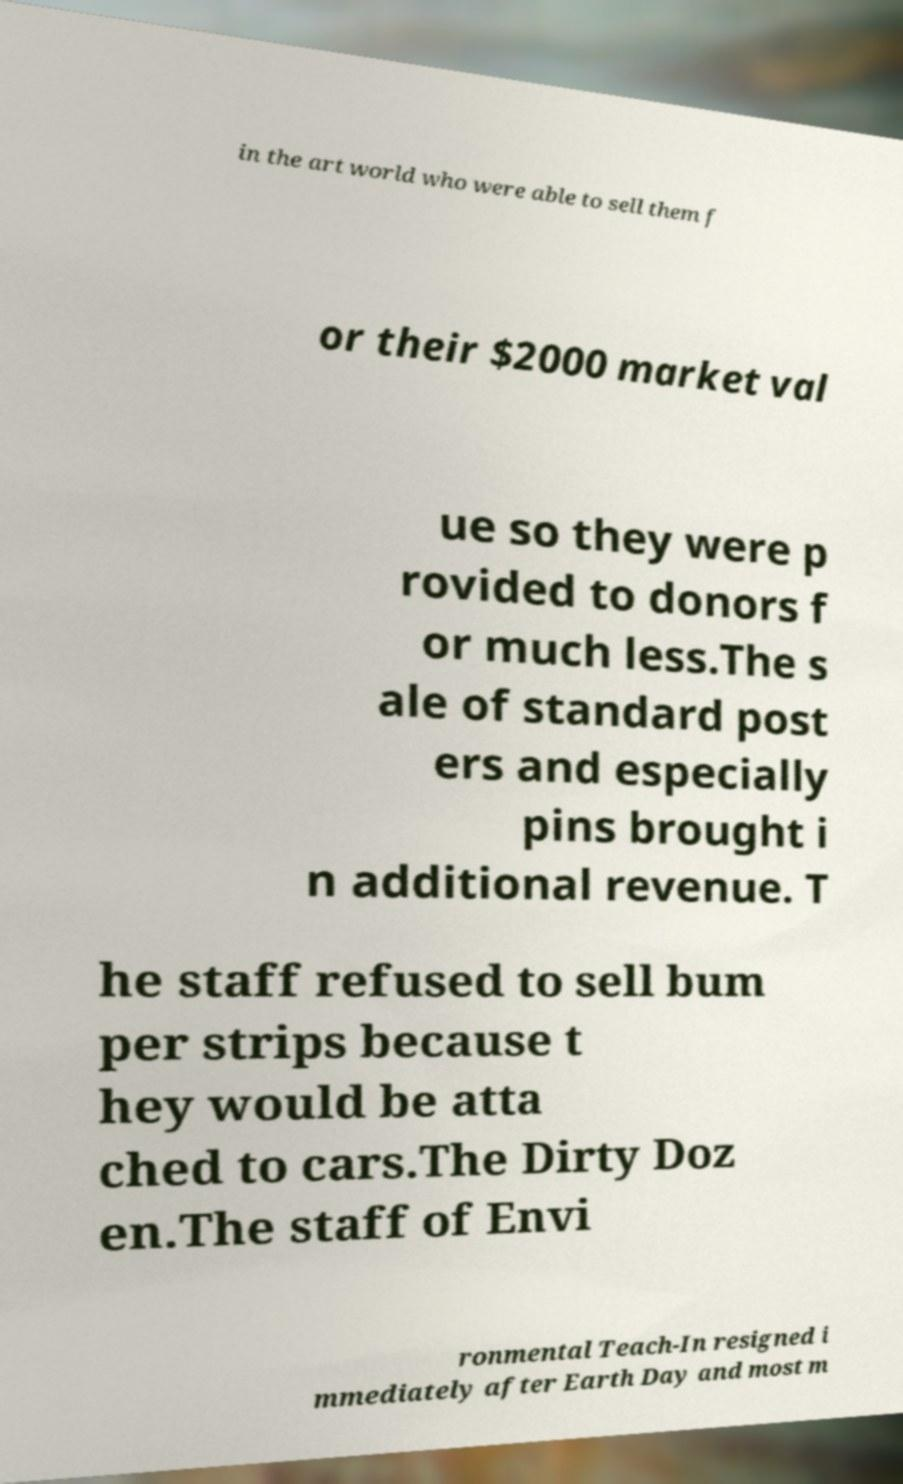Can you accurately transcribe the text from the provided image for me? in the art world who were able to sell them f or their $2000 market val ue so they were p rovided to donors f or much less.The s ale of standard post ers and especially pins brought i n additional revenue. T he staff refused to sell bum per strips because t hey would be atta ched to cars.The Dirty Doz en.The staff of Envi ronmental Teach-In resigned i mmediately after Earth Day and most m 